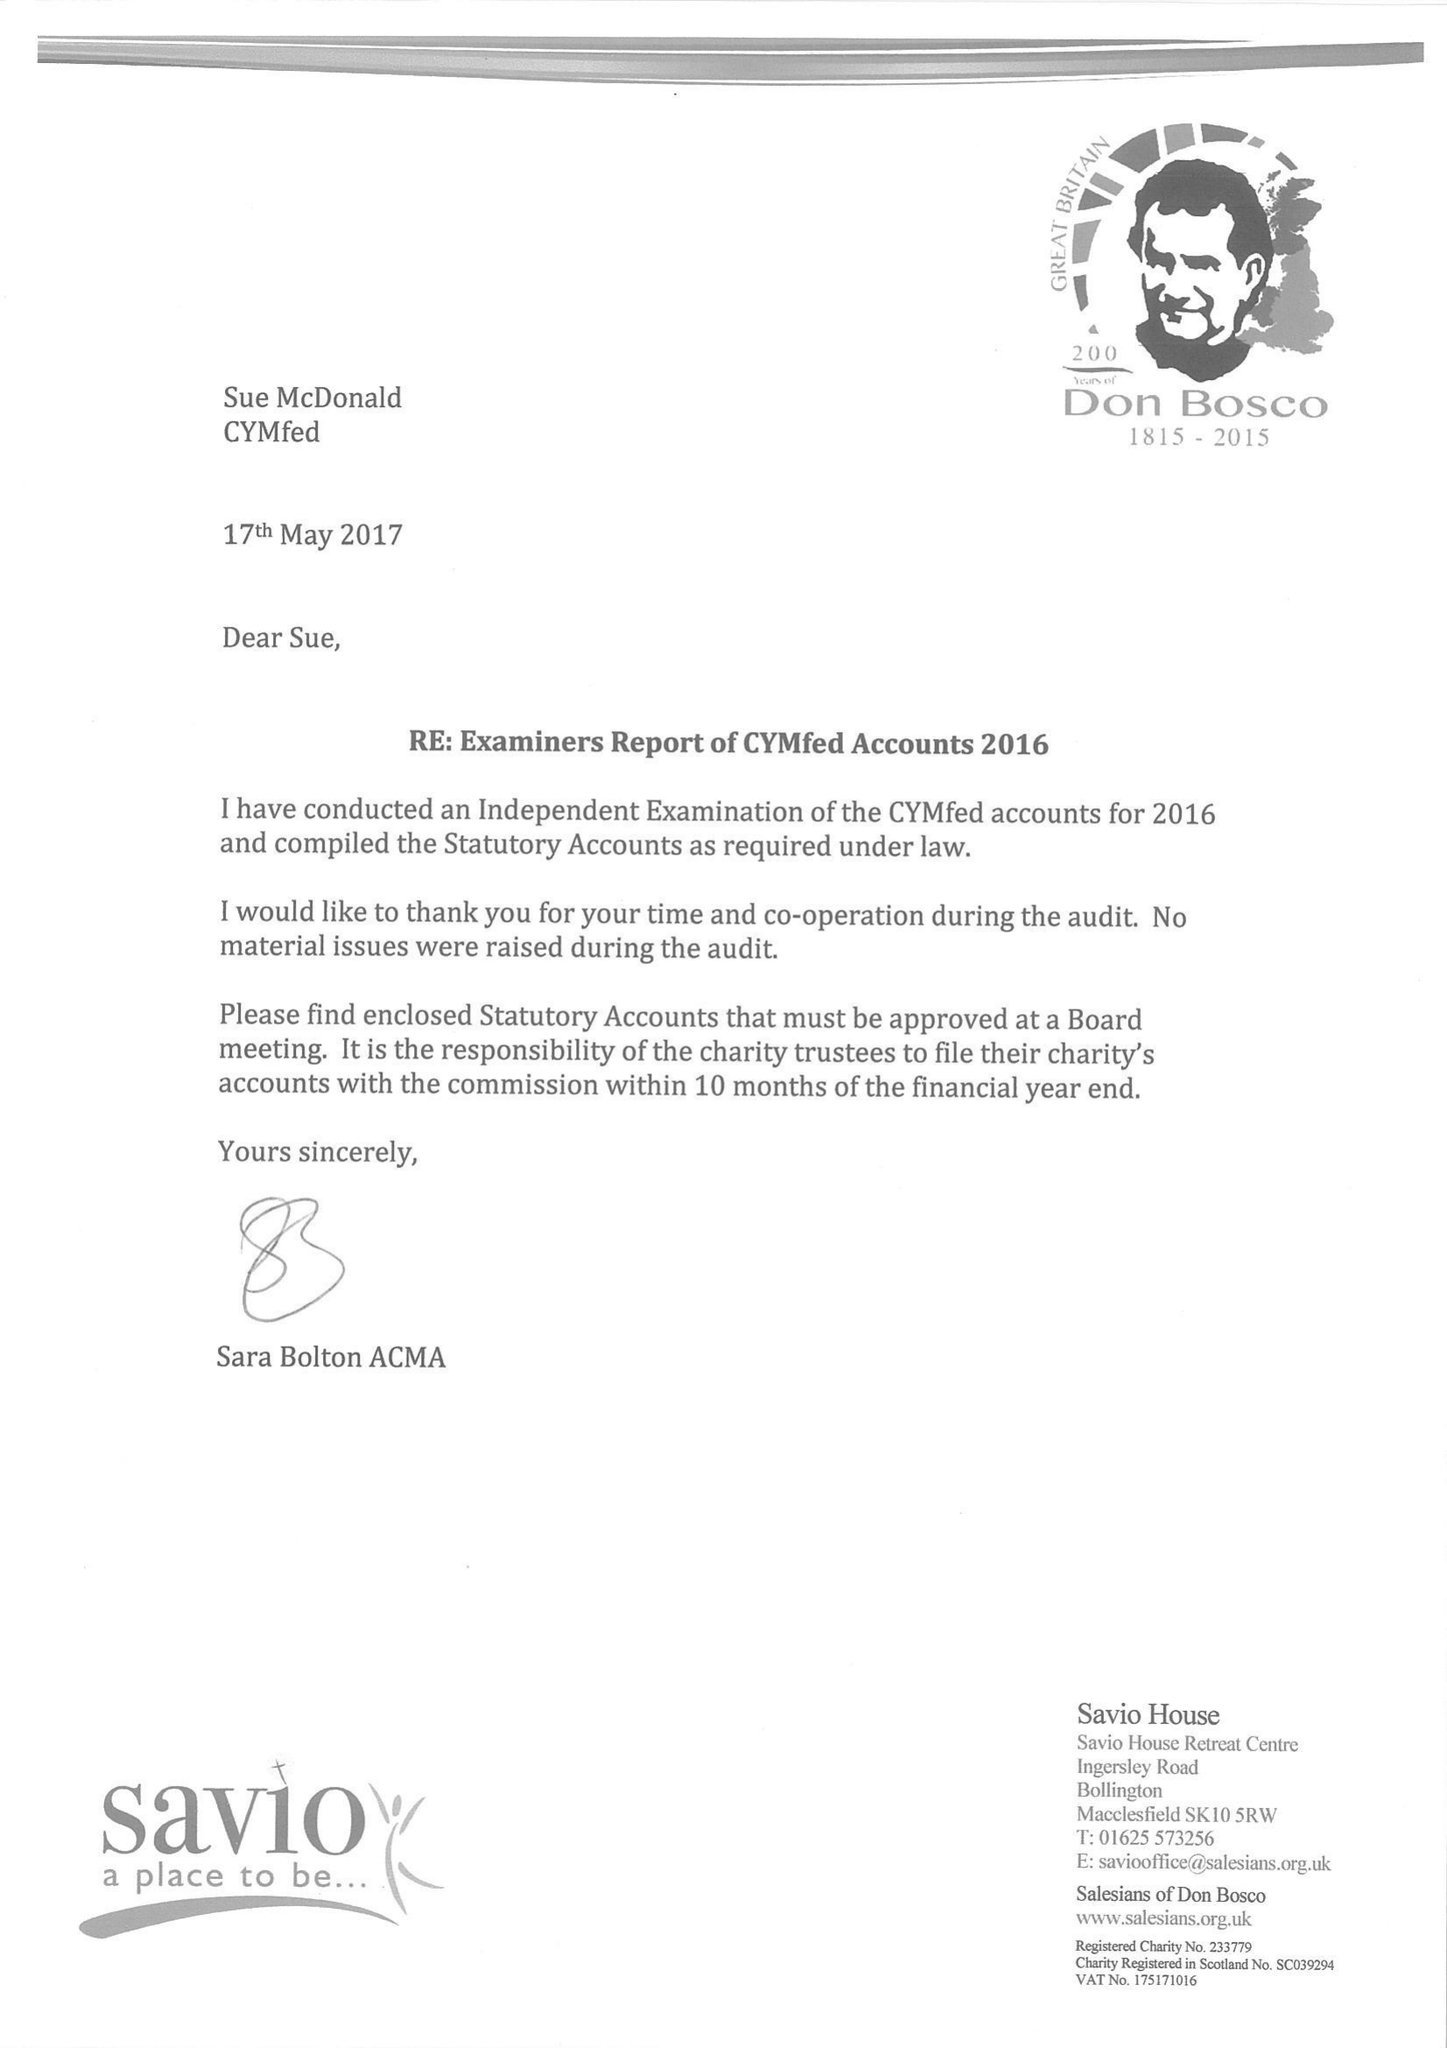What is the value for the address__post_town?
Answer the question using a single word or phrase. LONDON 